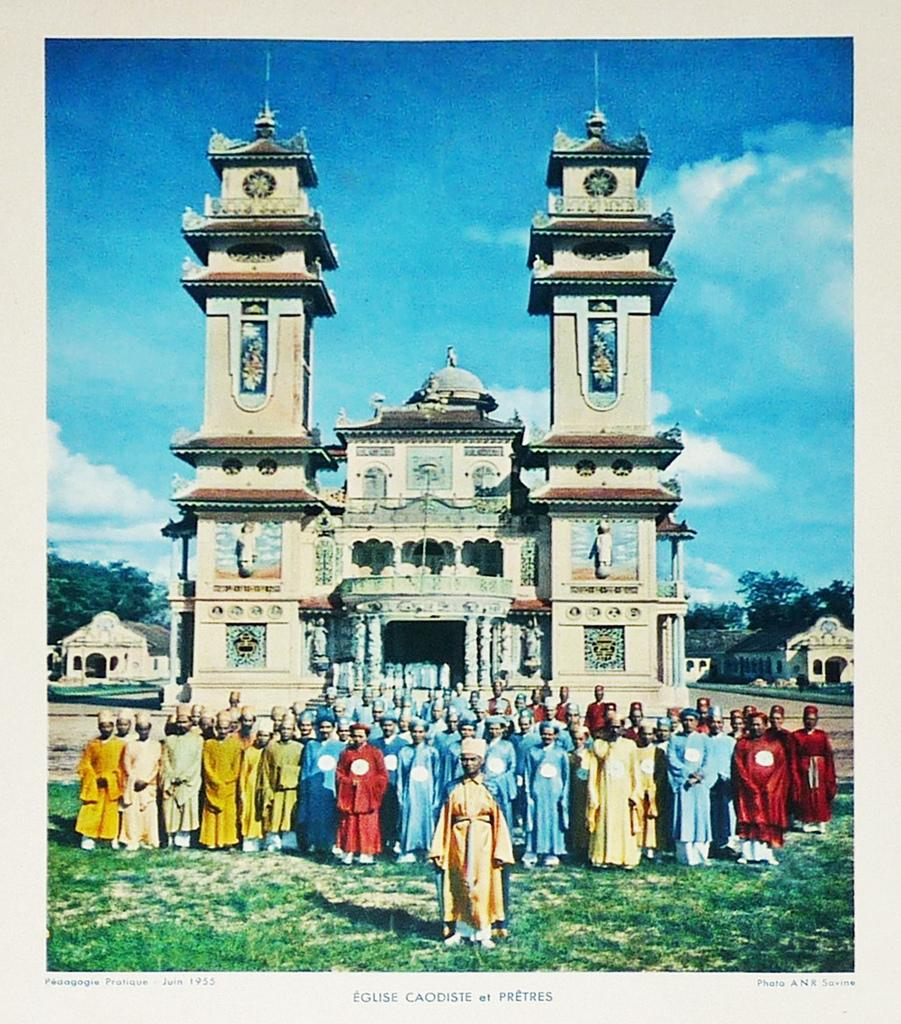What type of structure is in the image? There is a fort in the image. What is happening in front of the fort? There are people standing in front of the fort. What can be seen at the top of the image? The sky is visible at the top of the image. What other types of buildings are in the image? There are small houses in the image. What type of natural elements are present in the image? Trees are present in the image. How many clocks are hanging from the trees in the image? There are no clocks hanging from the trees in the image. What type of cloth is draped over the fort in the image? There is no cloth draped over the fort in the image? 